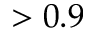<formula> <loc_0><loc_0><loc_500><loc_500>> 0 . 9</formula> 